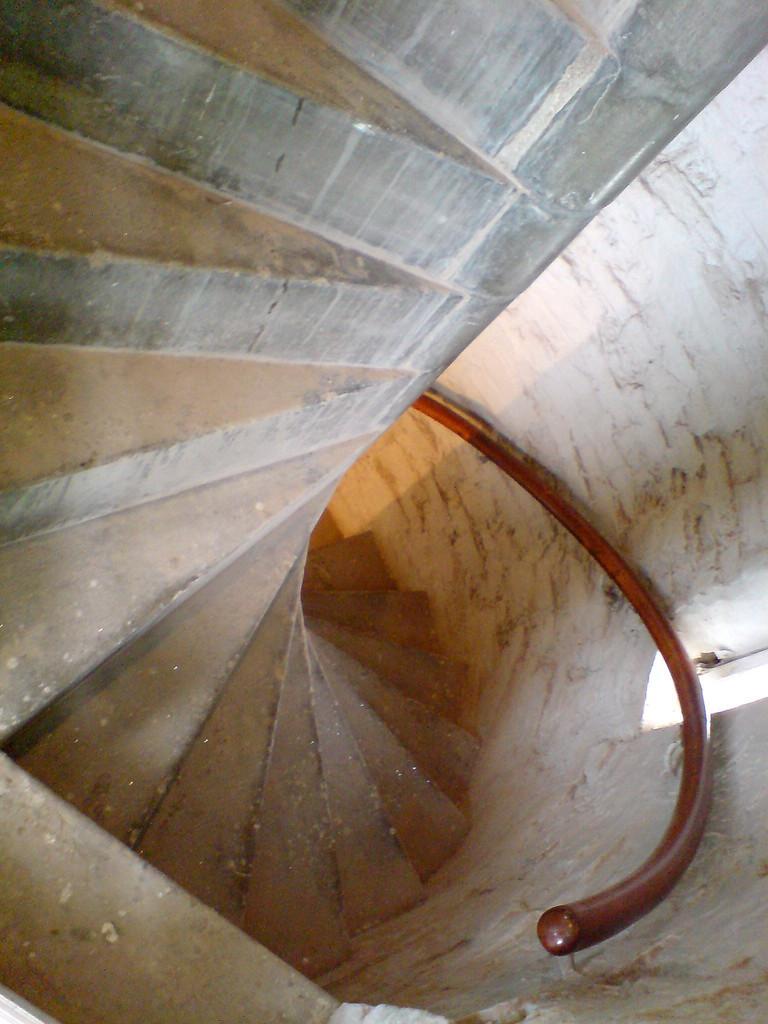In one or two sentences, can you explain what this image depicts? As we can see in the image there is a white color wall and stairs. 